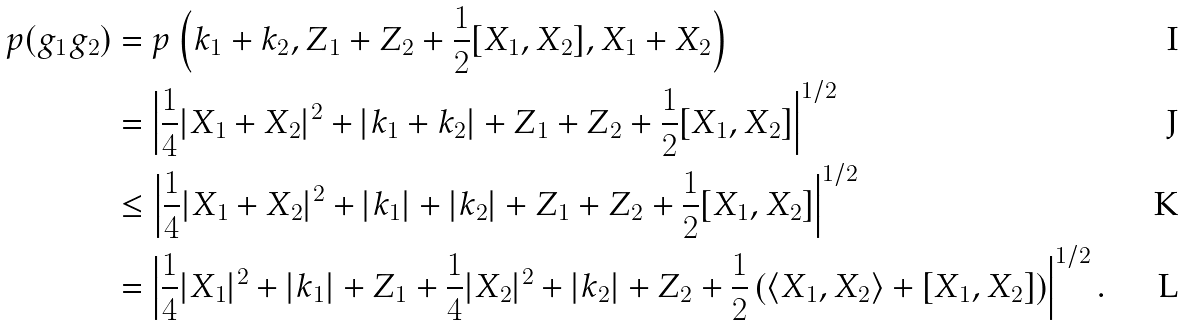Convert formula to latex. <formula><loc_0><loc_0><loc_500><loc_500>p ( g _ { 1 } g _ { 2 } ) & = p \left ( k _ { 1 } + k _ { 2 } , Z _ { 1 } + Z _ { 2 } + \frac { 1 } { 2 } [ X _ { 1 } , X _ { 2 } ] , X _ { 1 } + X _ { 2 } \right ) \\ & = \left | \frac { 1 } { 4 } | X _ { 1 } + X _ { 2 } | ^ { 2 } + | k _ { 1 } + k _ { 2 } | + Z _ { 1 } + Z _ { 2 } + \frac { 1 } { 2 } [ X _ { 1 } , X _ { 2 } ] \right | ^ { 1 / 2 } \\ & \leq \left | \frac { 1 } { 4 } | X _ { 1 } + X _ { 2 } | ^ { 2 } + | k _ { 1 } | + | k _ { 2 } | + Z _ { 1 } + Z _ { 2 } + \frac { 1 } { 2 } [ X _ { 1 } , X _ { 2 } ] \right | ^ { 1 / 2 } \\ & = \left | \frac { 1 } { 4 } | X _ { 1 } | ^ { 2 } + | k _ { 1 } | + Z _ { 1 } + \frac { 1 } { 4 } | X _ { 2 } | ^ { 2 } + | k _ { 2 } | + Z _ { 2 } + \frac { 1 } { 2 } \left ( \langle X _ { 1 } , X _ { 2 } \rangle + [ X _ { 1 } , X _ { 2 } ] \right ) \right | ^ { 1 / 2 } .</formula> 